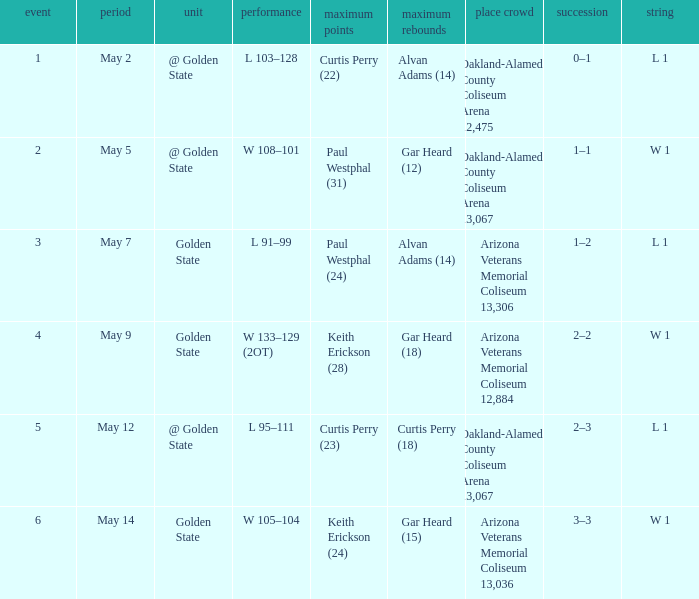How many games had they won or lost in a row on May 9? W 1. 